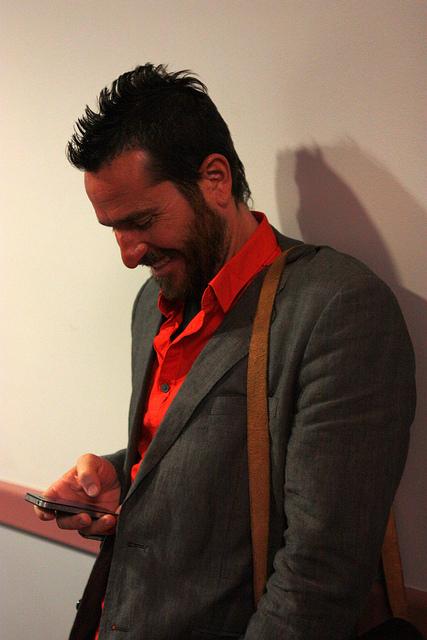What is this man holding?
Write a very short answer. Phone. Is the man dressed formally?
Answer briefly. Yes. Is the man wearing glasses?
Quick response, please. No. Is the man wearing a suit?
Concise answer only. Yes. Does the man look sad?
Quick response, please. No. 